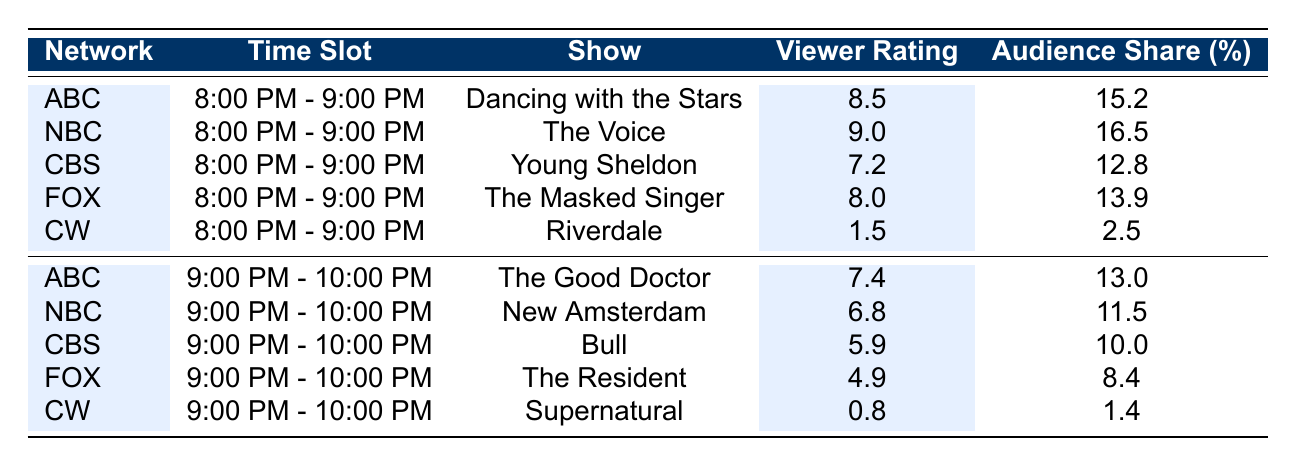What's the audience share for NBC's show in the 8:00 PM - 9:00 PM slot? The table shows that NBC's show "The Voice" has an audience share of 16.5% during the 8:00 PM - 9:00 PM time slot.
Answer: 16.5% Which show has the highest viewer rating in the 9:00 PM - 10:00 PM slot? By comparing the viewer ratings for the 9:00 PM - 10:00 PM time slot, "The Good Doctor" on ABC has the highest rating at 7.4, while other shows have lower ratings.
Answer: The Good Doctor Is ABC's viewer rating higher than CBS's in the 8:00 PM - 9:00 PM time slot? The viewer rating for ABC's "Dancing with the Stars" is 8.5, which is higher than CBS's "Young Sheldon," which has a rating of 7.2. Therefore, ABC's rating is higher.
Answer: Yes What is the average viewer rating for the shows in the 8:00 PM - 9:00 PM time slot? The viewer ratings for this slot are 8.5, 9.0, 7.2, 8.0, and 1.5. The sum of these ratings is 34.2, and there are 5 shows, so the average is 34.2 divided by 5, which equals 6.84.
Answer: 6.84 Does FOX have a higher audience share than CW in the 9:00 PM - 10:00 PM slot? FOX's show "The Resident" has an audience share of 8.4%, while CW's "Supernatural" has a much lower audience share of 1.4%. Therefore, FOX's share is higher than CW's.
Answer: Yes What is the total viewer rating for the shows broadcasted by CBS during prime time? CBS's viewer ratings are 7.2 (for Young Sheldon) and 5.9 (for Bull). Adding these together gives a total viewer rating of 13.1 for CBS.
Answer: 13.1 Which network has the lowest audience share across all prime time slots? By comparing the audience shares, CW has the lowest audience share in both prime time slots, with shares of 2.5% and 1.4%.
Answer: CW What is the difference in viewer ratings between NBC's show at 8:00 PM - 9:00 PM and the same network's show at 9:00 PM - 10:00 PM? NBC's viewer rating for "The Voice" is 9.0, and for "New Amsterdam" it is 6.8. The difference is 9.0 minus 6.8, which equals 2.2.
Answer: 2.2 Which network's show experienced the most significant drop in viewer ratings from the 8:00 PM - 9:00 PM time slot to 9:00 PM - 10:00 PM time slot? Comparing the ratings, CW's "Riverdale" dropped from 1.5 to 0.8, which is a decrease of 0.7. Other networks either increased or dropped less than that.
Answer: CW 